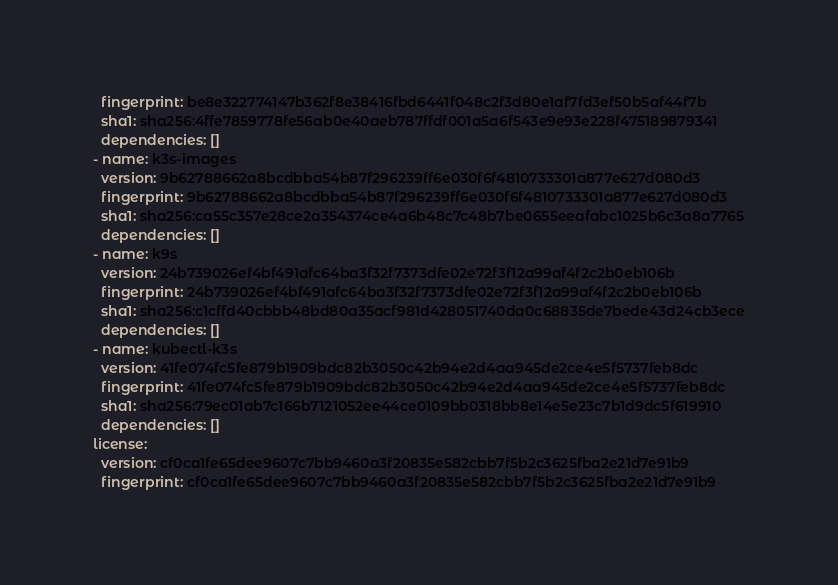<code> <loc_0><loc_0><loc_500><loc_500><_YAML_>  fingerprint: be8e322774147b362f8e38416fbd6441f048c2f3d80e1af7fd3ef50b5af44f7b
  sha1: sha256:4ffe7859778fe56ab0e40aeb787ffdf001a5a6f543e9e93e228f475189879341
  dependencies: []
- name: k3s-images
  version: 9b62788662a8bcdbba54b87f296239ff6e030f6f4810733301a877e627d080d3
  fingerprint: 9b62788662a8bcdbba54b87f296239ff6e030f6f4810733301a877e627d080d3
  sha1: sha256:ca55c357e28ce2a354374ce4a6b48c7c48b7be0655eeafabc1025b6c3a8a7765
  dependencies: []
- name: k9s
  version: 24b739026ef4bf491afc64ba3f32f7373dfe02e72f3f12a99af4f2c2b0eb106b
  fingerprint: 24b739026ef4bf491afc64ba3f32f7373dfe02e72f3f12a99af4f2c2b0eb106b
  sha1: sha256:c1cffd40cbbb48bd80a35acf981d428051740da0c68835de7bede43d24cb3ece
  dependencies: []
- name: kubectl-k3s
  version: 41fe074fc5fe879b1909bdc82b3050c42b94e2d4aa945de2ce4e5f5737feb8dc
  fingerprint: 41fe074fc5fe879b1909bdc82b3050c42b94e2d4aa945de2ce4e5f5737feb8dc
  sha1: sha256:79ec01ab7c166b7121052ee44ce0109bb0318bb8e14e5e23c7b1d9dc5f619910
  dependencies: []
license:
  version: cf0ca1fe65dee9607c7bb9460a3f20835e582cbb7f5b2c3625fba2e21d7e91b9
  fingerprint: cf0ca1fe65dee9607c7bb9460a3f20835e582cbb7f5b2c3625fba2e21d7e91b9</code> 